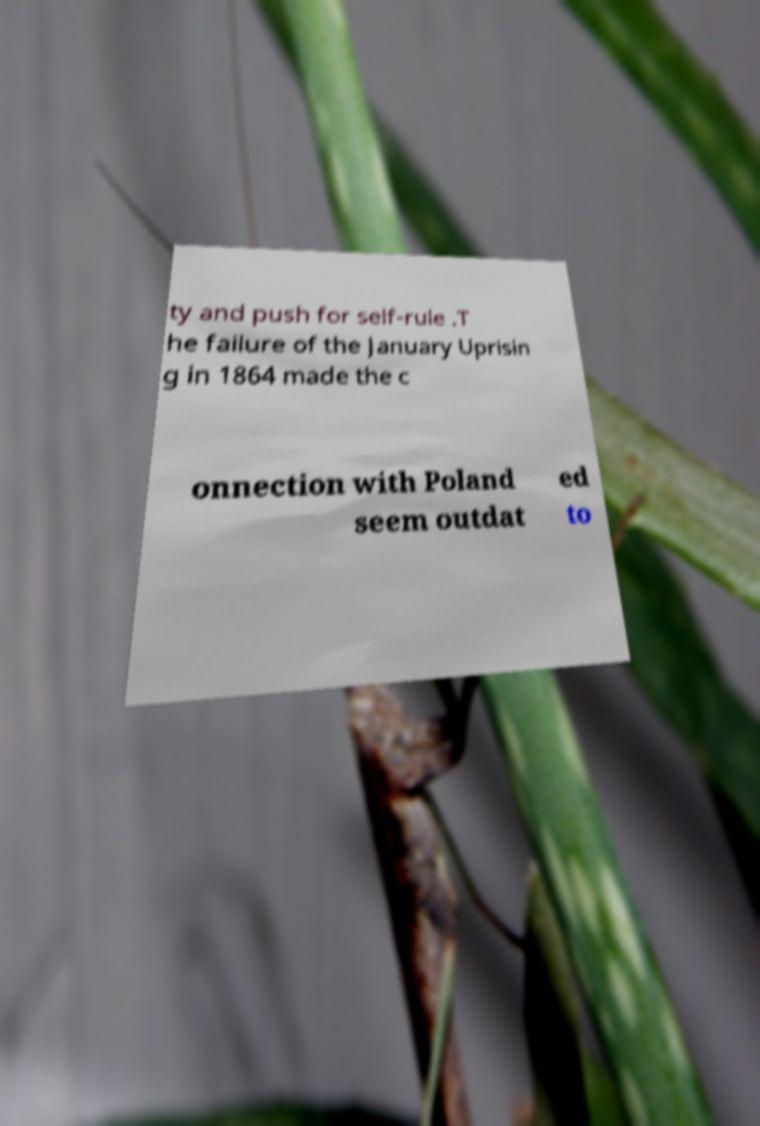For documentation purposes, I need the text within this image transcribed. Could you provide that? ty and push for self-rule .T he failure of the January Uprisin g in 1864 made the c onnection with Poland seem outdat ed to 